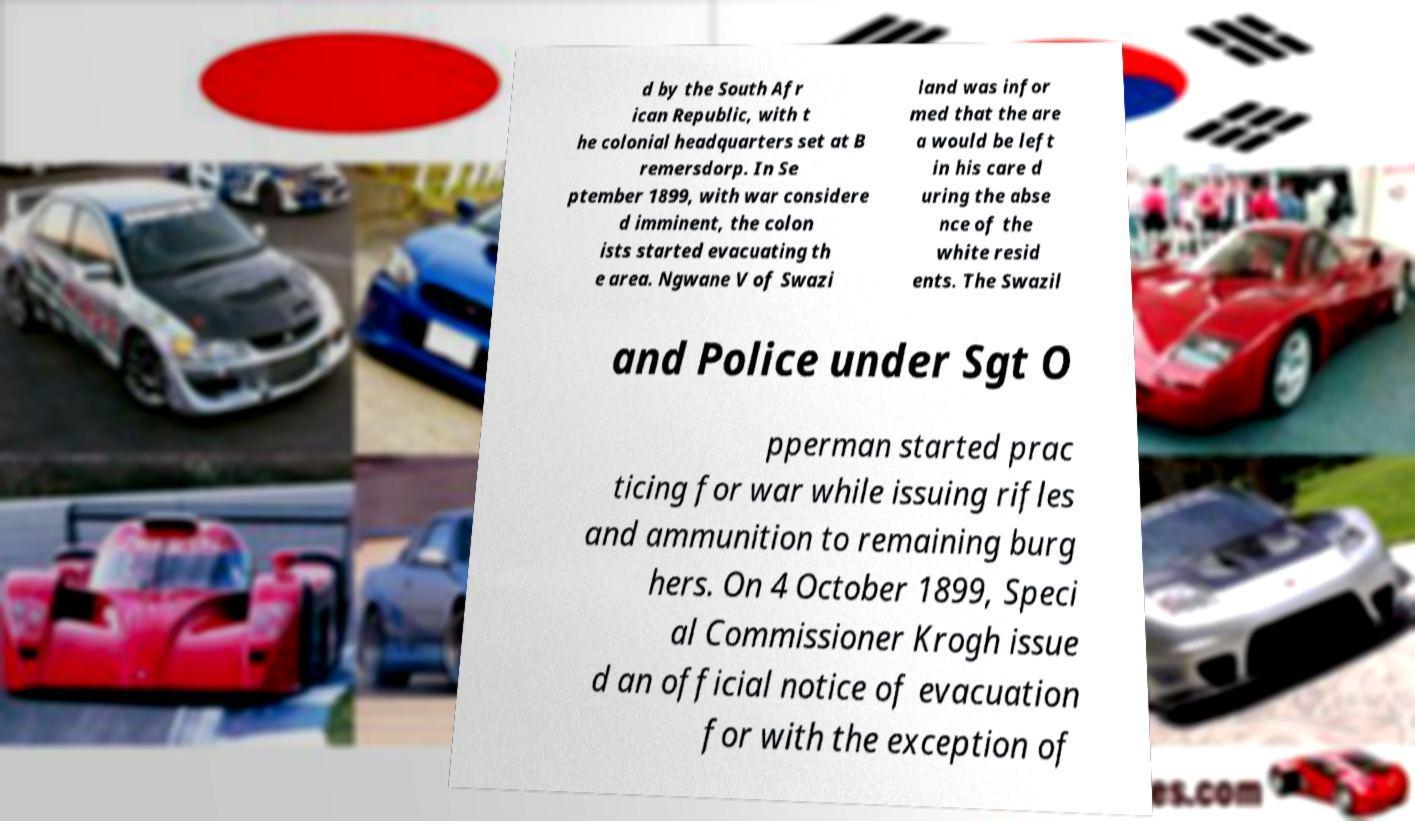What messages or text are displayed in this image? I need them in a readable, typed format. d by the South Afr ican Republic, with t he colonial headquarters set at B remersdorp. In Se ptember 1899, with war considere d imminent, the colon ists started evacuating th e area. Ngwane V of Swazi land was infor med that the are a would be left in his care d uring the abse nce of the white resid ents. The Swazil and Police under Sgt O pperman started prac ticing for war while issuing rifles and ammunition to remaining burg hers. On 4 October 1899, Speci al Commissioner Krogh issue d an official notice of evacuation for with the exception of 